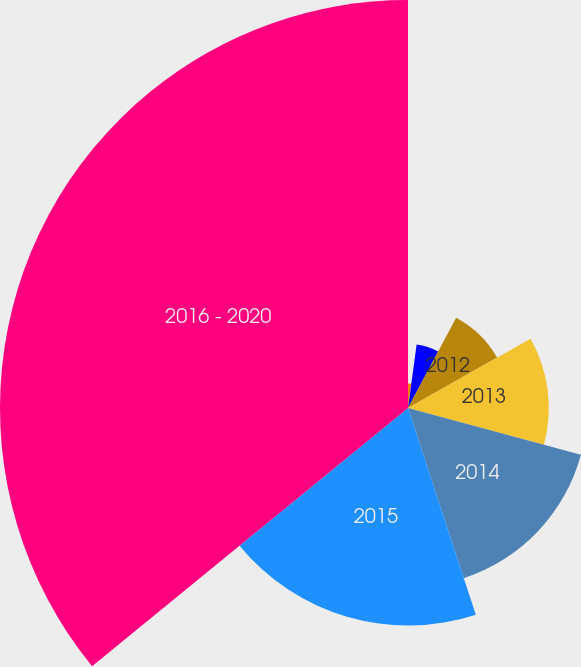Convert chart to OTSL. <chart><loc_0><loc_0><loc_500><loc_500><pie_chart><fcel>Expected employer contribution<fcel>2011<fcel>2012<fcel>2013<fcel>2014<fcel>2015<fcel>2016 - 2020<nl><fcel>2.15%<fcel>5.64%<fcel>9.01%<fcel>12.39%<fcel>15.76%<fcel>19.14%<fcel>35.9%<nl></chart> 